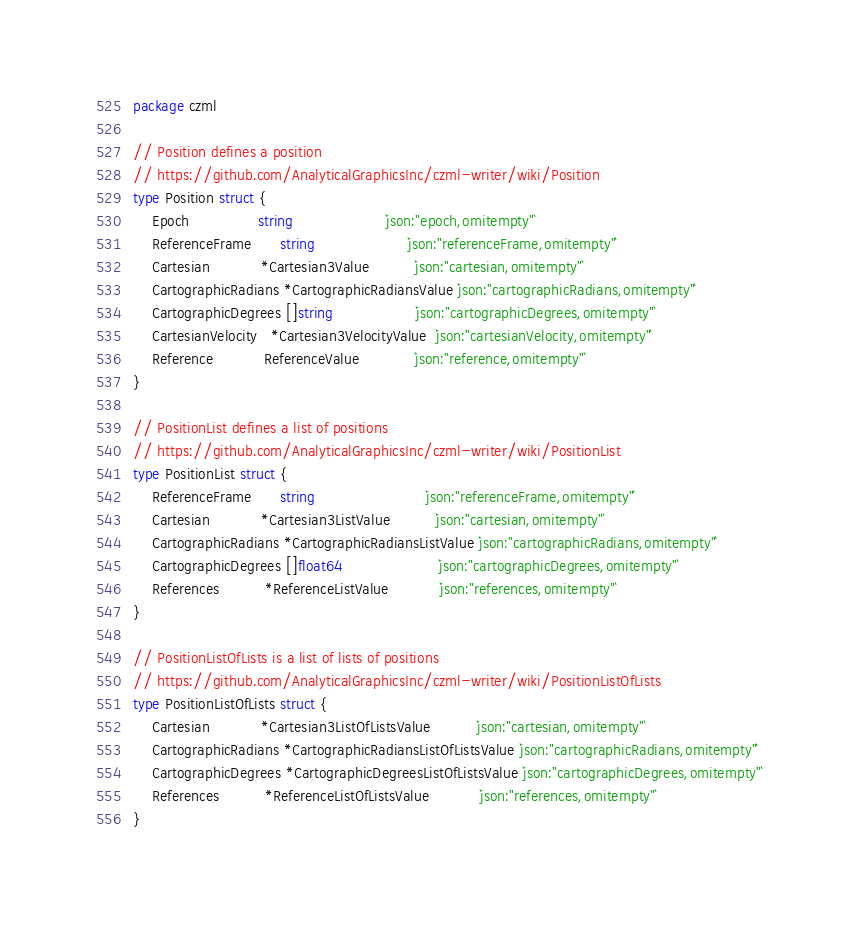<code> <loc_0><loc_0><loc_500><loc_500><_Go_>package czml

// Position defines a position
// https://github.com/AnalyticalGraphicsInc/czml-writer/wiki/Position
type Position struct {
	Epoch               string                    `json:"epoch,omitempty"`
	ReferenceFrame      string                    `json:"referenceFrame,omitempty"`
	Cartesian           *Cartesian3Value          `json:"cartesian,omitempty"`
	CartographicRadians *CartographicRadiansValue `json:"cartographicRadians,omitempty"`
	CartographicDegrees []string                  `json:"cartographicDegrees,omitempty"`
	CartesianVelocity   *Cartesian3VelocityValue  `json:"cartesianVelocity,omitempty"`
	Reference           ReferenceValue            `json:"reference,omitempty"`
}

// PositionList defines a list of positions
// https://github.com/AnalyticalGraphicsInc/czml-writer/wiki/PositionList
type PositionList struct {
	ReferenceFrame      string                        `json:"referenceFrame,omitempty"`
	Cartesian           *Cartesian3ListValue          `json:"cartesian,omitempty"`
	CartographicRadians *CartographicRadiansListValue `json:"cartographicRadians,omitempty"`
	CartographicDegrees []float64                     `json:"cartographicDegrees,omitempty"`
	References          *ReferenceListValue           `json:"references,omitempty"`
}

// PositionListOfLists is a list of lists of positions
// https://github.com/AnalyticalGraphicsInc/czml-writer/wiki/PositionListOfLists
type PositionListOfLists struct {
	Cartesian           *Cartesian3ListOfListsValue          `json:"cartesian,omitempty"`
	CartographicRadians *CartographicRadiansListOfListsValue `json:"cartographicRadians,omitempty"`
	CartographicDegrees *CartographicDegreesListOfListsValue `json:"cartographicDegrees,omitempty"`
	References          *ReferenceListOfListsValue           `json:"references,omitempty"`
}
</code> 